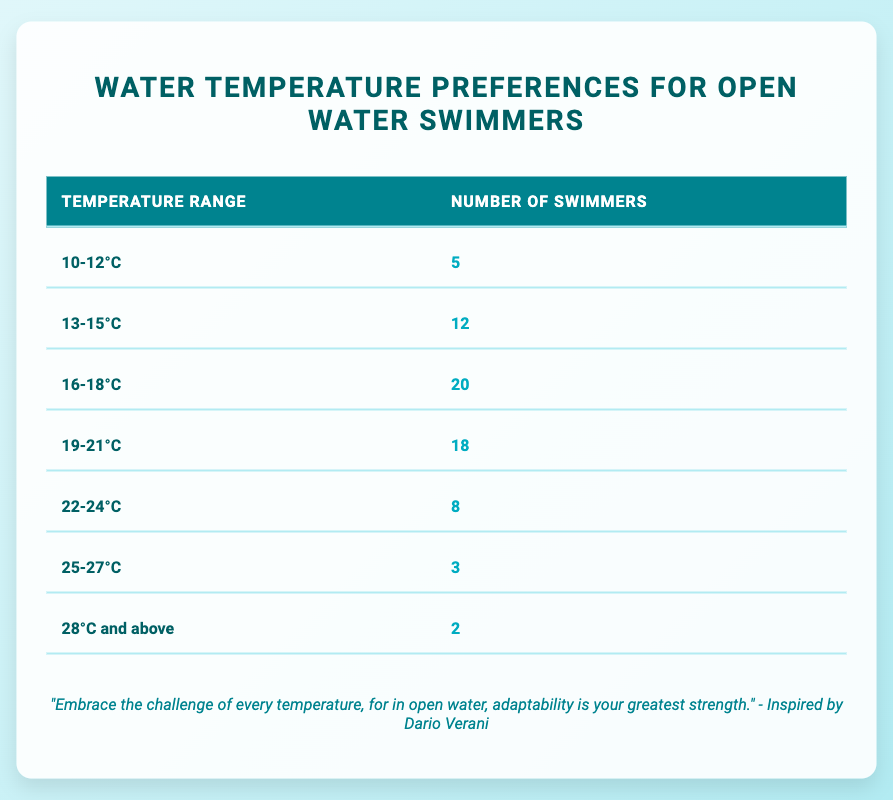What is the most popular water temperature range among the swimmers? The most popular temperature range can be determined by looking for the highest swimmer count in the table. The temperature range "16-18°C" has the highest count of 20 swimmers.
Answer: 16-18°C How many swimmers prefer temperatures lower than 19°C? To find the number of swimmers who prefer temperatures lower than 19°C, we sum the counts for the ranges "10-12°C" (5), "13-15°C" (12), and "16-18°C" (20). The total is 5 + 12 + 20 = 37.
Answer: 37 Is there a temperature range that has more than 15 swimmers? We check each swimmer count in the table to see if any exceeds 15. The "16-18°C" (20) and "19-21°C" (18) ranges both exceed 15 swimmers. Therefore, the statement is true.
Answer: Yes What is the total number of swimmers surveyed? To find the total number of swimmers, we add all the swimmer counts together from the table: 5 + 12 + 20 + 18 + 8 + 3 + 2 = 78.
Answer: 78 What is the difference in the number of swimmers between the "19-21°C" and "22-24°C" ranges? To find the difference, we'll subtract the count of the "22-24°C" range (8) from the "19-21°C" range (18). The calculation is 18 - 8 = 10.
Answer: 10 Which temperature range has the least number of swimmers? By examining the swimmer counts in the table, the range with the fewest swimmers is "28°C and above" with 2 swimmers.
Answer: 28°C and above What percentage of swimmers prefer temperatures between 19°C and 24°C? First, we find the total count of swimmers who prefer the ranges "19-21°C" (18) and "22-24°C" (8), which totals 18 + 8 = 26. Next, we calculate the percentage of this total out of the overall 78 swimmers: (26/78) * 100 = approximately 33.33%.
Answer: 33.33% How many swimmers prefer 25°C and above? For this, we add the swimmer counts for the ranges "25-27°C" (3) and "28°C and above" (2). 3 + 2 = 5 swimmers prefer these temperatures.
Answer: 5 